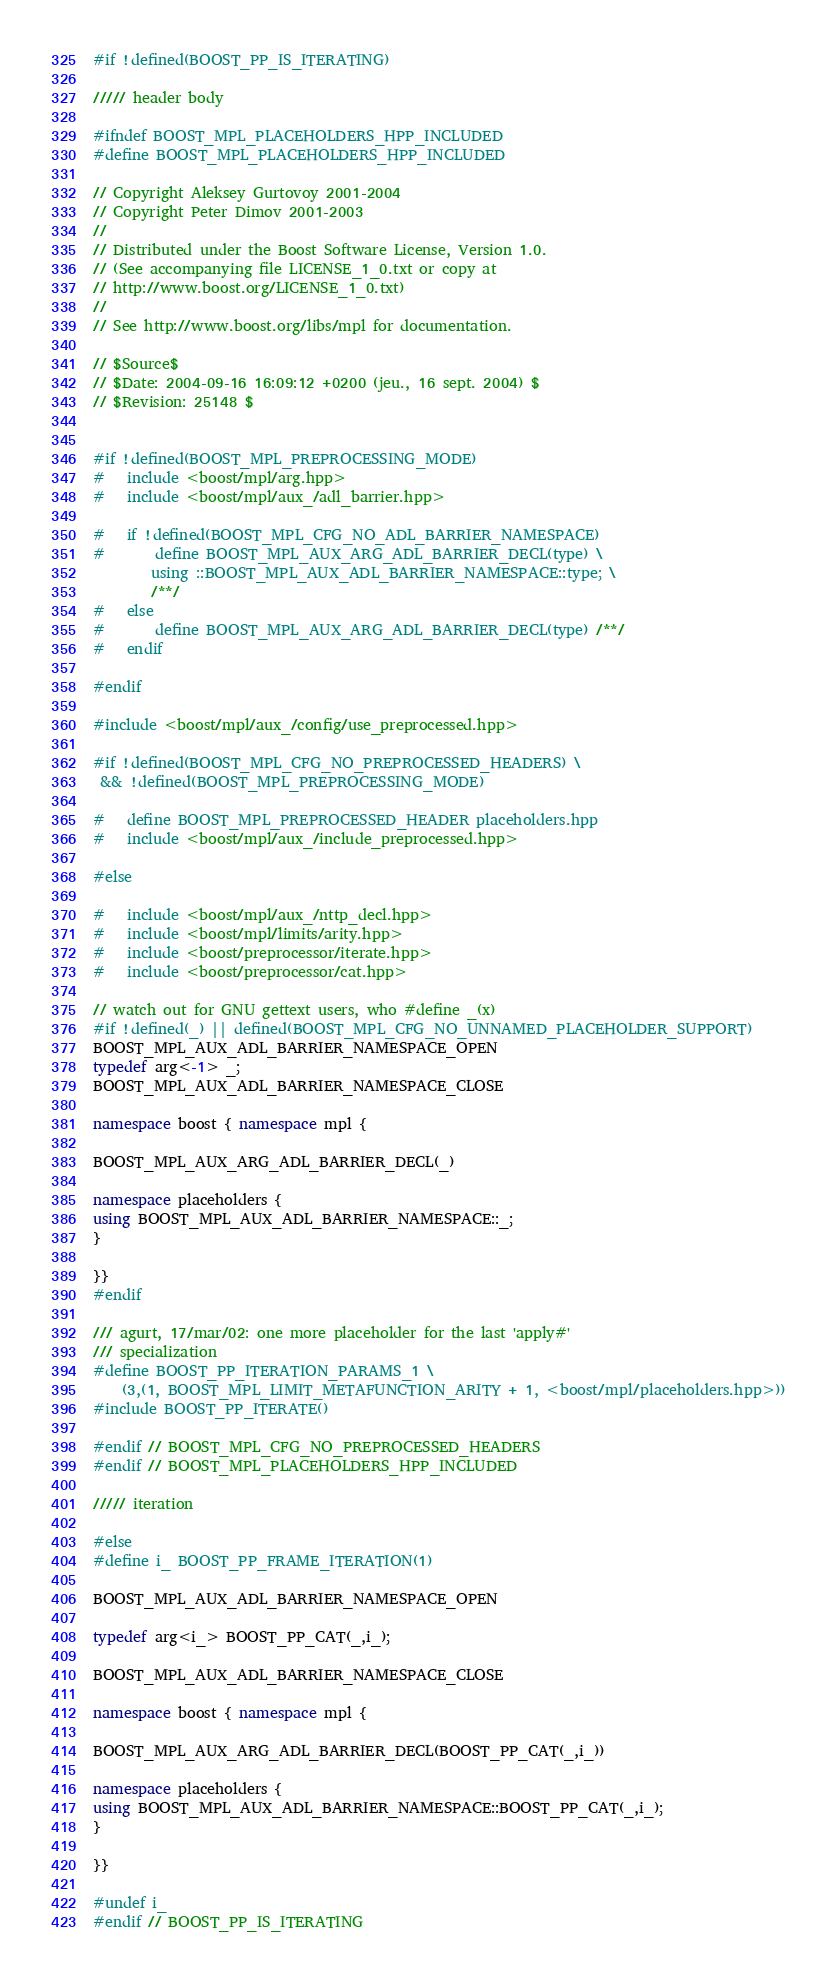<code> <loc_0><loc_0><loc_500><loc_500><_C++_>
#if !defined(BOOST_PP_IS_ITERATING)

///// header body

#ifndef BOOST_MPL_PLACEHOLDERS_HPP_INCLUDED
#define BOOST_MPL_PLACEHOLDERS_HPP_INCLUDED

// Copyright Aleksey Gurtovoy 2001-2004
// Copyright Peter Dimov 2001-2003
//
// Distributed under the Boost Software License, Version 1.0. 
// (See accompanying file LICENSE_1_0.txt or copy at 
// http://www.boost.org/LICENSE_1_0.txt)
//
// See http://www.boost.org/libs/mpl for documentation.

// $Source$
// $Date: 2004-09-16 16:09:12 +0200 (jeu., 16 sept. 2004) $
// $Revision: 25148 $


#if !defined(BOOST_MPL_PREPROCESSING_MODE)
#   include <boost/mpl/arg.hpp>
#   include <boost/mpl/aux_/adl_barrier.hpp>

#   if !defined(BOOST_MPL_CFG_NO_ADL_BARRIER_NAMESPACE)
#       define BOOST_MPL_AUX_ARG_ADL_BARRIER_DECL(type) \
        using ::BOOST_MPL_AUX_ADL_BARRIER_NAMESPACE::type; \
        /**/
#   else
#       define BOOST_MPL_AUX_ARG_ADL_BARRIER_DECL(type) /**/
#   endif

#endif

#include <boost/mpl/aux_/config/use_preprocessed.hpp>

#if !defined(BOOST_MPL_CFG_NO_PREPROCESSED_HEADERS) \
 && !defined(BOOST_MPL_PREPROCESSING_MODE)

#   define BOOST_MPL_PREPROCESSED_HEADER placeholders.hpp
#   include <boost/mpl/aux_/include_preprocessed.hpp>

#else

#   include <boost/mpl/aux_/nttp_decl.hpp>
#   include <boost/mpl/limits/arity.hpp>
#   include <boost/preprocessor/iterate.hpp>
#   include <boost/preprocessor/cat.hpp>

// watch out for GNU gettext users, who #define _(x)
#if !defined(_) || defined(BOOST_MPL_CFG_NO_UNNAMED_PLACEHOLDER_SUPPORT)
BOOST_MPL_AUX_ADL_BARRIER_NAMESPACE_OPEN
typedef arg<-1> _;
BOOST_MPL_AUX_ADL_BARRIER_NAMESPACE_CLOSE

namespace boost { namespace mpl { 

BOOST_MPL_AUX_ARG_ADL_BARRIER_DECL(_)

namespace placeholders {
using BOOST_MPL_AUX_ADL_BARRIER_NAMESPACE::_;
}

}}
#endif

/// agurt, 17/mar/02: one more placeholder for the last 'apply#' 
/// specialization
#define BOOST_PP_ITERATION_PARAMS_1 \
    (3,(1, BOOST_MPL_LIMIT_METAFUNCTION_ARITY + 1, <boost/mpl/placeholders.hpp>))
#include BOOST_PP_ITERATE()

#endif // BOOST_MPL_CFG_NO_PREPROCESSED_HEADERS
#endif // BOOST_MPL_PLACEHOLDERS_HPP_INCLUDED

///// iteration

#else
#define i_ BOOST_PP_FRAME_ITERATION(1)

BOOST_MPL_AUX_ADL_BARRIER_NAMESPACE_OPEN

typedef arg<i_> BOOST_PP_CAT(_,i_);

BOOST_MPL_AUX_ADL_BARRIER_NAMESPACE_CLOSE

namespace boost { namespace mpl { 

BOOST_MPL_AUX_ARG_ADL_BARRIER_DECL(BOOST_PP_CAT(_,i_))

namespace placeholders {
using BOOST_MPL_AUX_ADL_BARRIER_NAMESPACE::BOOST_PP_CAT(_,i_);
}

}}

#undef i_
#endif // BOOST_PP_IS_ITERATING
</code> 